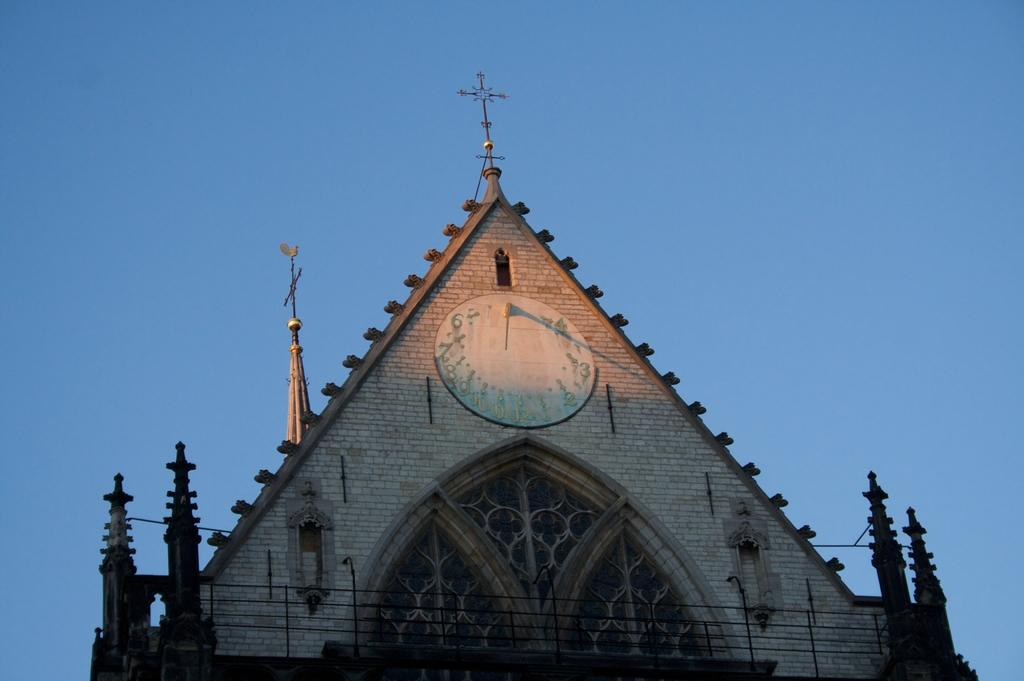What is the main structure in the image? There is a building in the image. What feature can be seen on the building? The building has a clock on it. What can be seen in the background of the image? There is sky visible in the background of the image. How many balls are being balanced on the clock in the image? There are no balls present in the image, and the clock is not being used for balancing anything. 